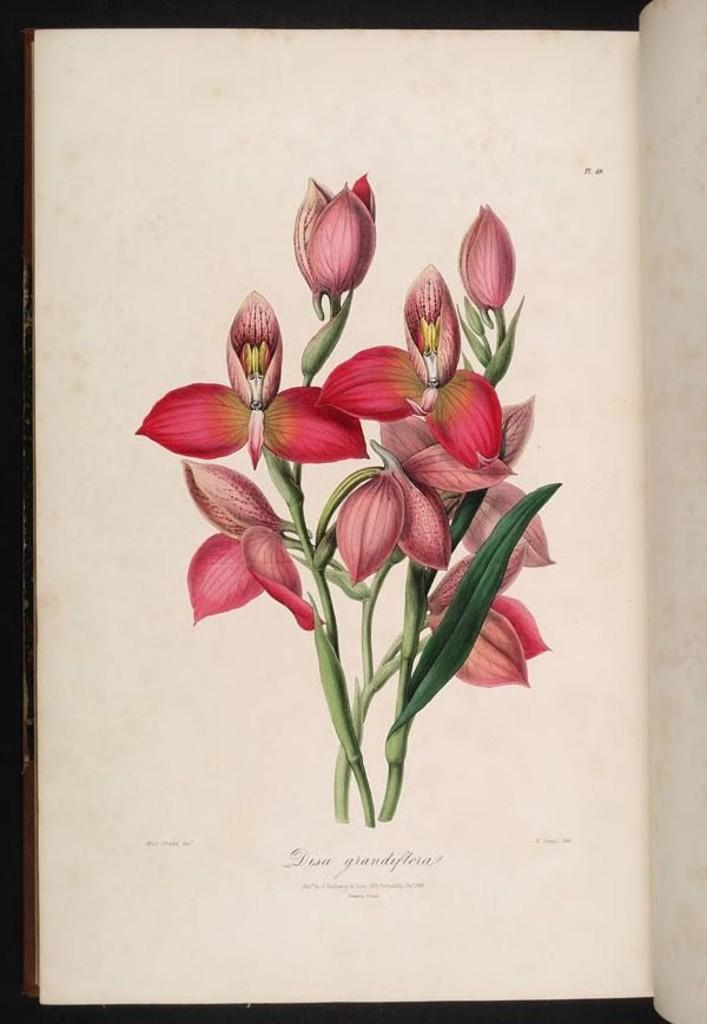What is the main object in the image? There is a book in the image. What type of image is included in the book? The image is of flowers. What are the flowers' parts that can be seen in the image? The image includes stems and leaves. Is there any text in the image? Yes, there is text written at the bottom of the image. What is the result of the competition shown in the image? There is no competition present in the image; it features a book with an image of flowers and text. 